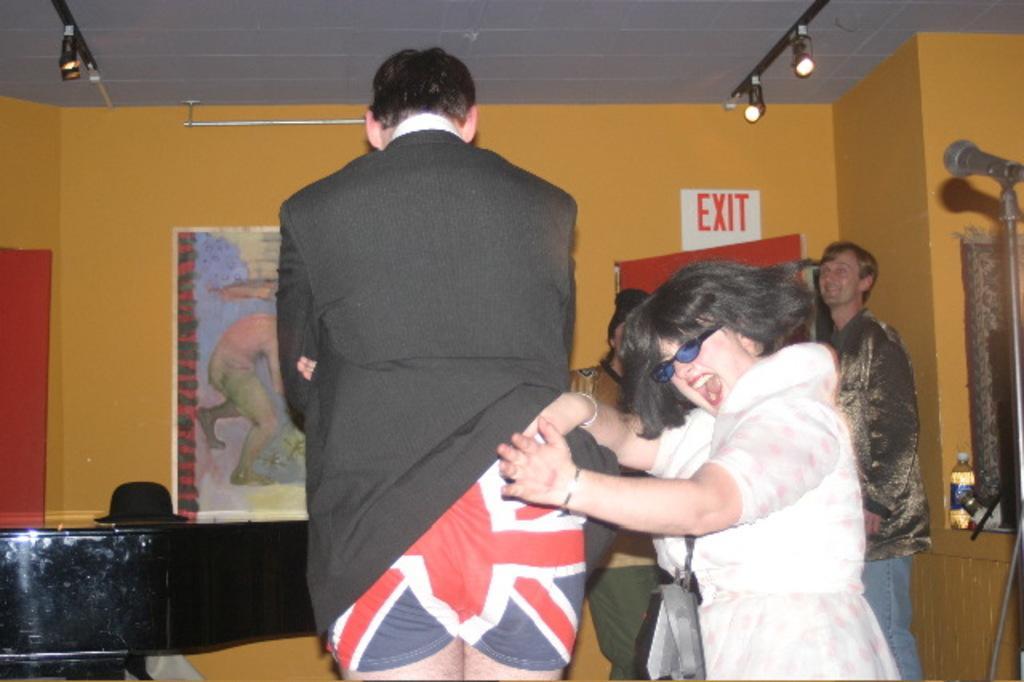In one or two sentences, can you explain what this image depicts? This picture is clicked inside the room. On the right we can see a person wearing white color dress and standing. In the center we can see a person standing and we can see a microphone attached to the metal stand and we can see the group of persons. In the background we can see the wall and we can see the picture of a person on an object and we can see a hat, bottle, lamps, roof and many other objects. 